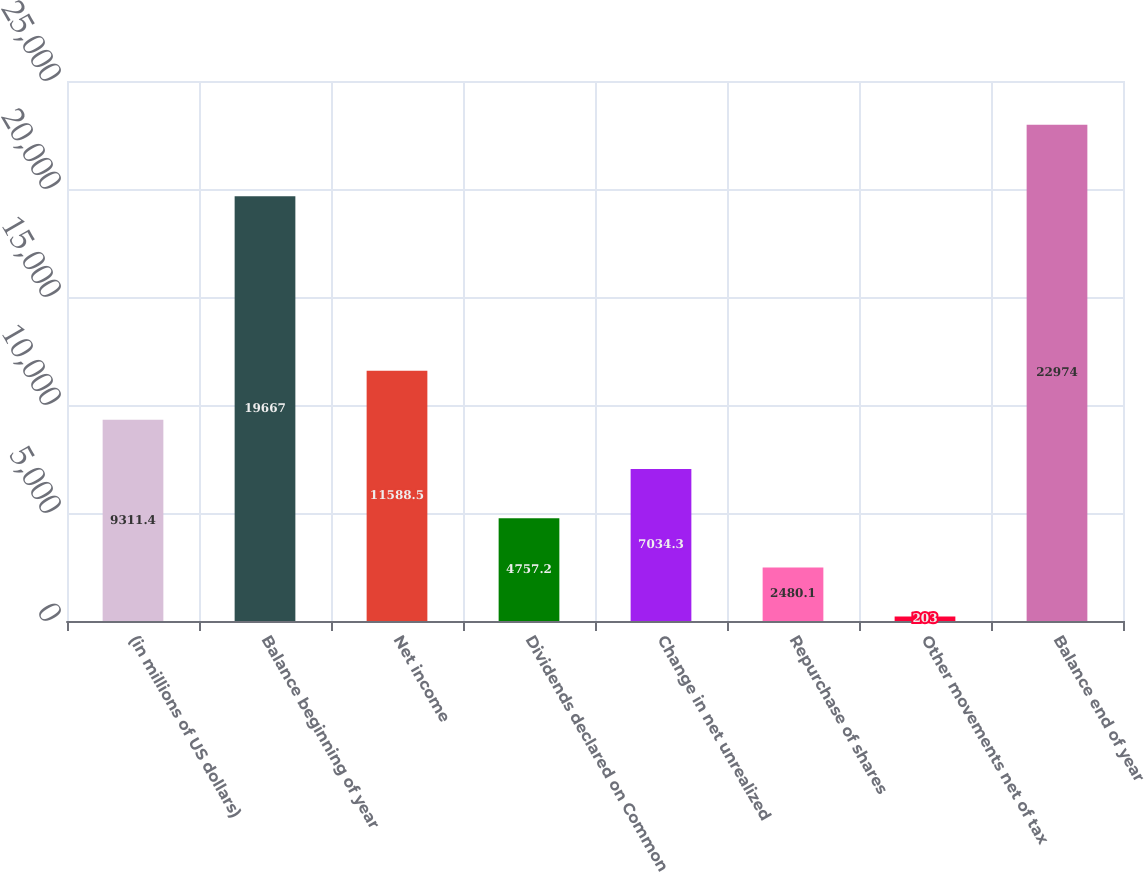<chart> <loc_0><loc_0><loc_500><loc_500><bar_chart><fcel>(in millions of US dollars)<fcel>Balance beginning of year<fcel>Net income<fcel>Dividends declared on Common<fcel>Change in net unrealized<fcel>Repurchase of shares<fcel>Other movements net of tax<fcel>Balance end of year<nl><fcel>9311.4<fcel>19667<fcel>11588.5<fcel>4757.2<fcel>7034.3<fcel>2480.1<fcel>203<fcel>22974<nl></chart> 